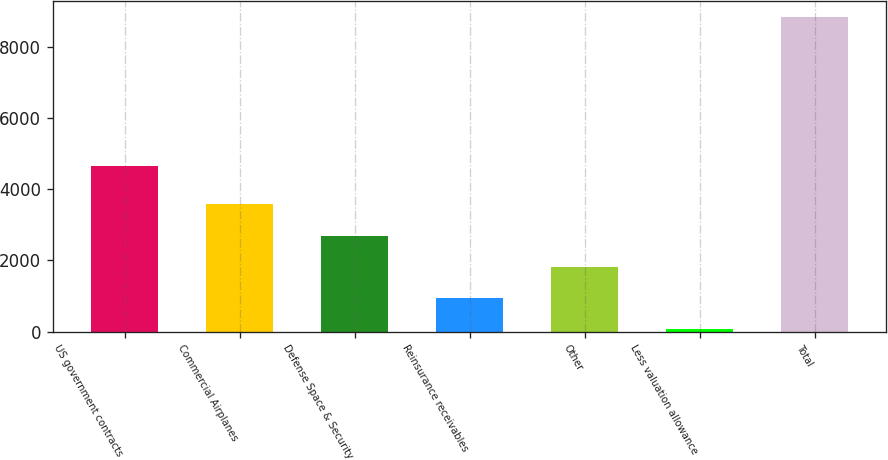<chart> <loc_0><loc_0><loc_500><loc_500><bar_chart><fcel>US government contracts<fcel>Commercial Airplanes<fcel>Defense Space & Security<fcel>Reinsurance receivables<fcel>Other<fcel>Less valuation allowance<fcel>Total<nl><fcel>4639<fcel>3571.8<fcel>2695.1<fcel>941.7<fcel>1818.4<fcel>65<fcel>8832<nl></chart> 